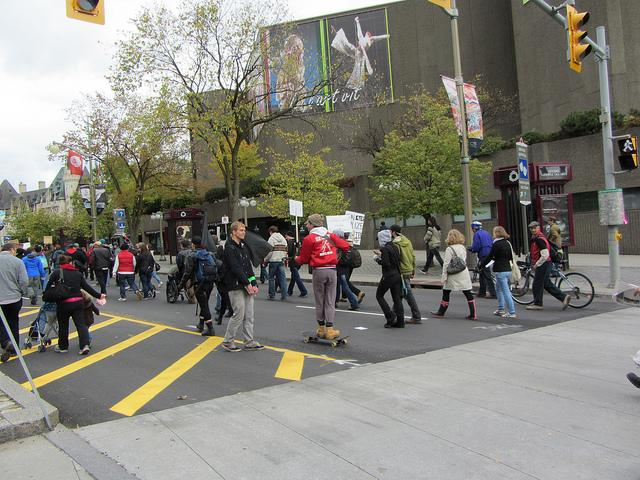What type of area is shown? street 